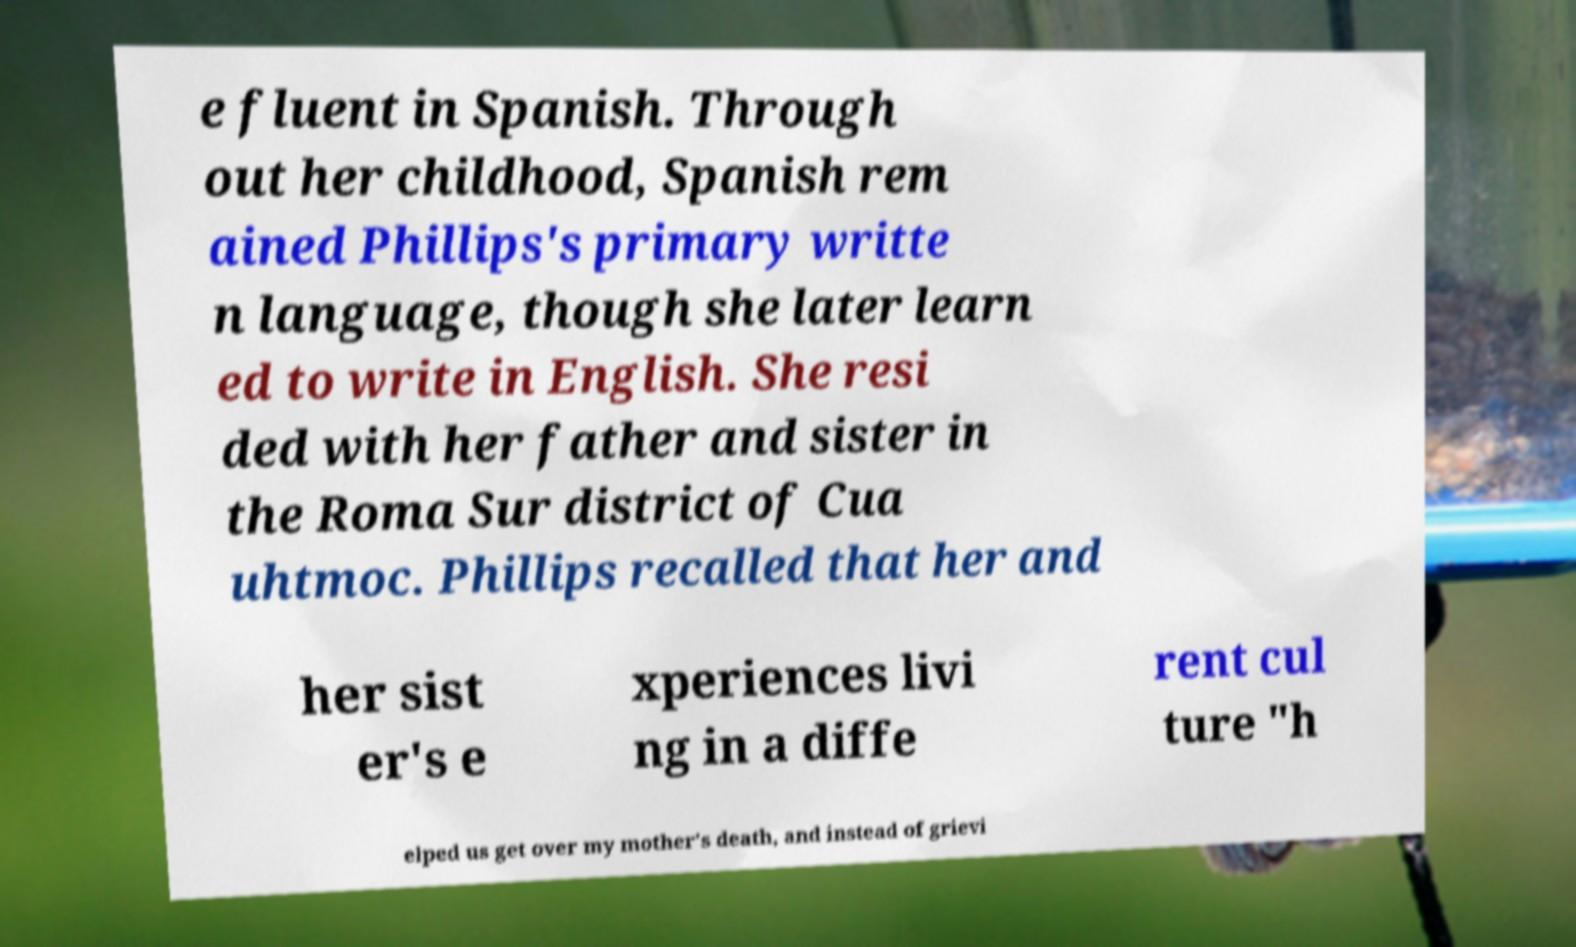What messages or text are displayed in this image? I need them in a readable, typed format. e fluent in Spanish. Through out her childhood, Spanish rem ained Phillips's primary writte n language, though she later learn ed to write in English. She resi ded with her father and sister in the Roma Sur district of Cua uhtmoc. Phillips recalled that her and her sist er's e xperiences livi ng in a diffe rent cul ture "h elped us get over my mother's death, and instead of grievi 